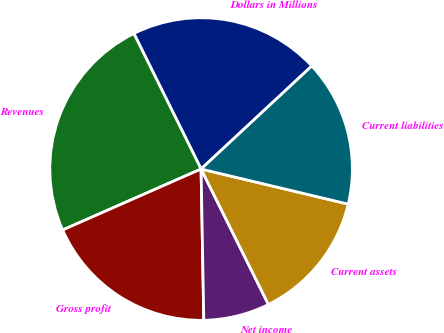Convert chart to OTSL. <chart><loc_0><loc_0><loc_500><loc_500><pie_chart><fcel>Dollars in Millions<fcel>Revenues<fcel>Gross profit<fcel>Net income<fcel>Current assets<fcel>Current liabilities<nl><fcel>20.4%<fcel>24.27%<fcel>18.68%<fcel>7.06%<fcel>13.93%<fcel>15.65%<nl></chart> 